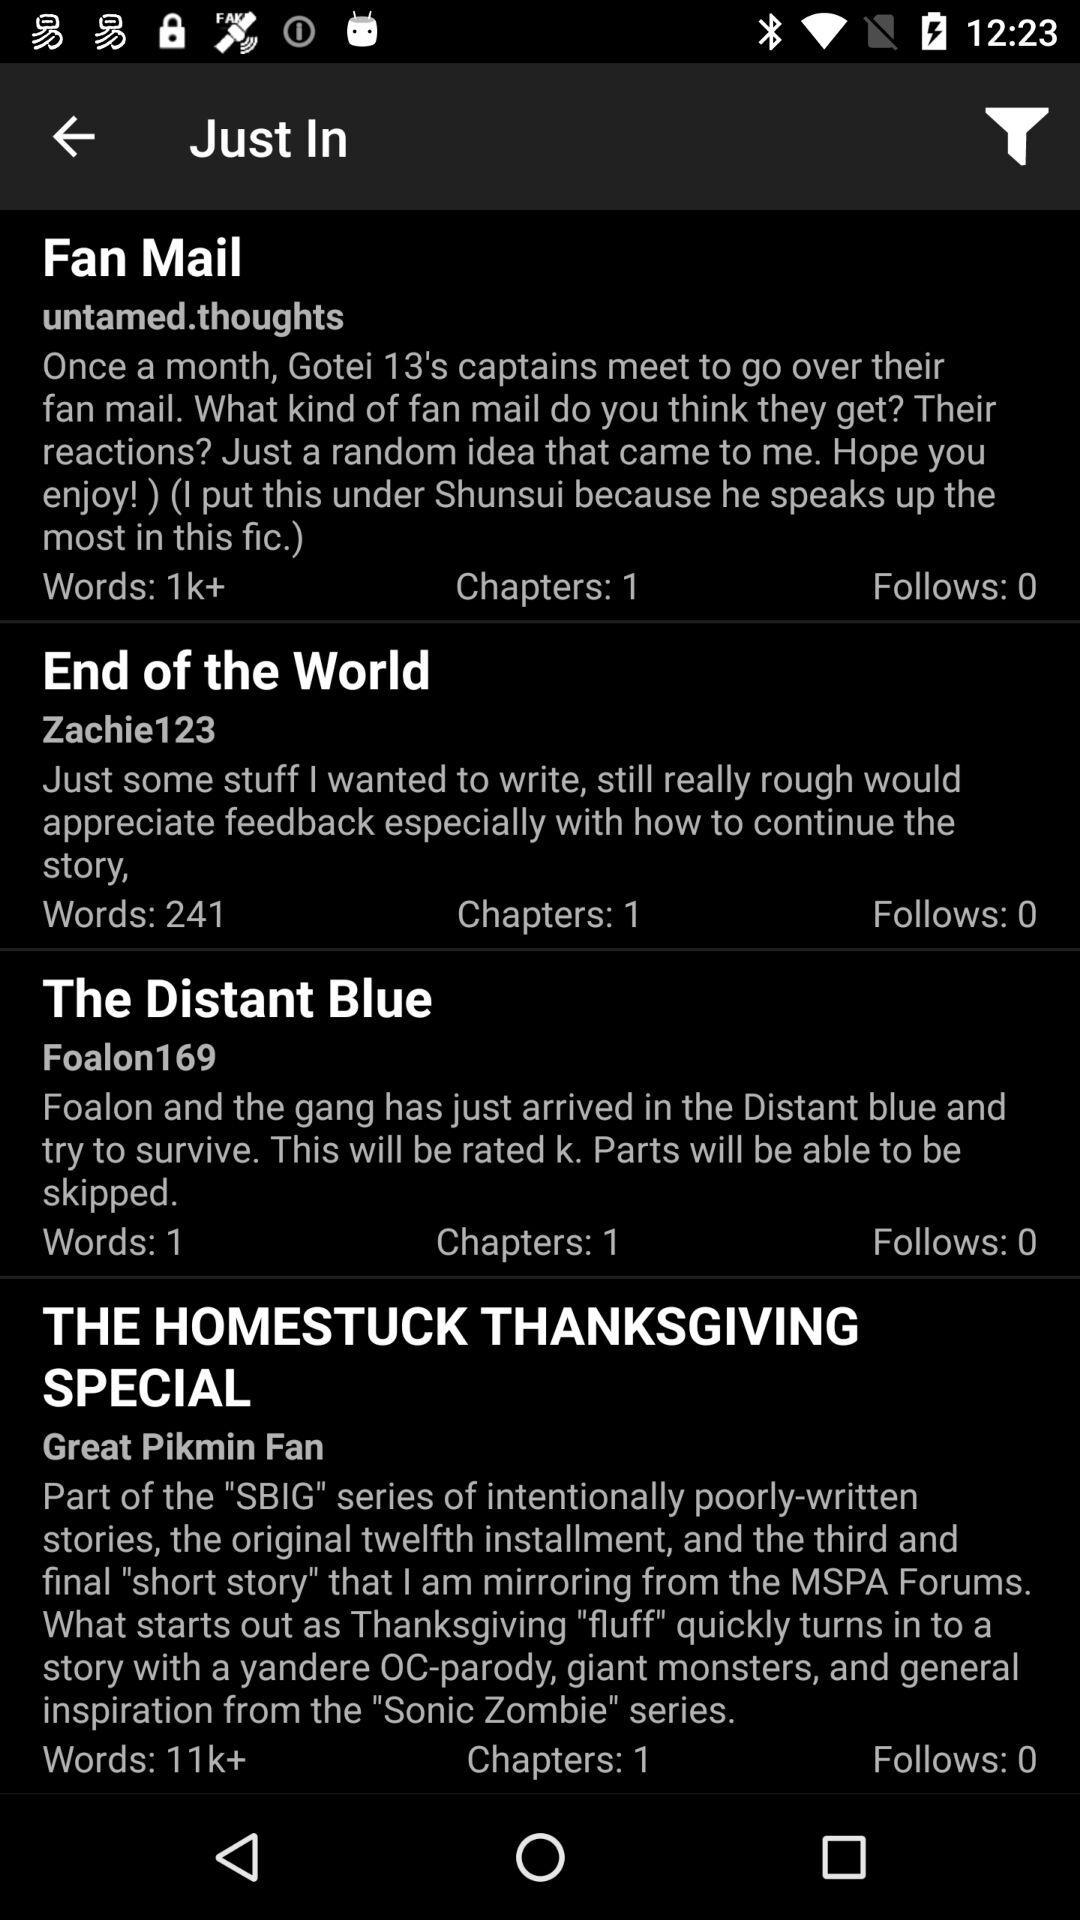How many words are there in "End of the World"? There are 241 words. 